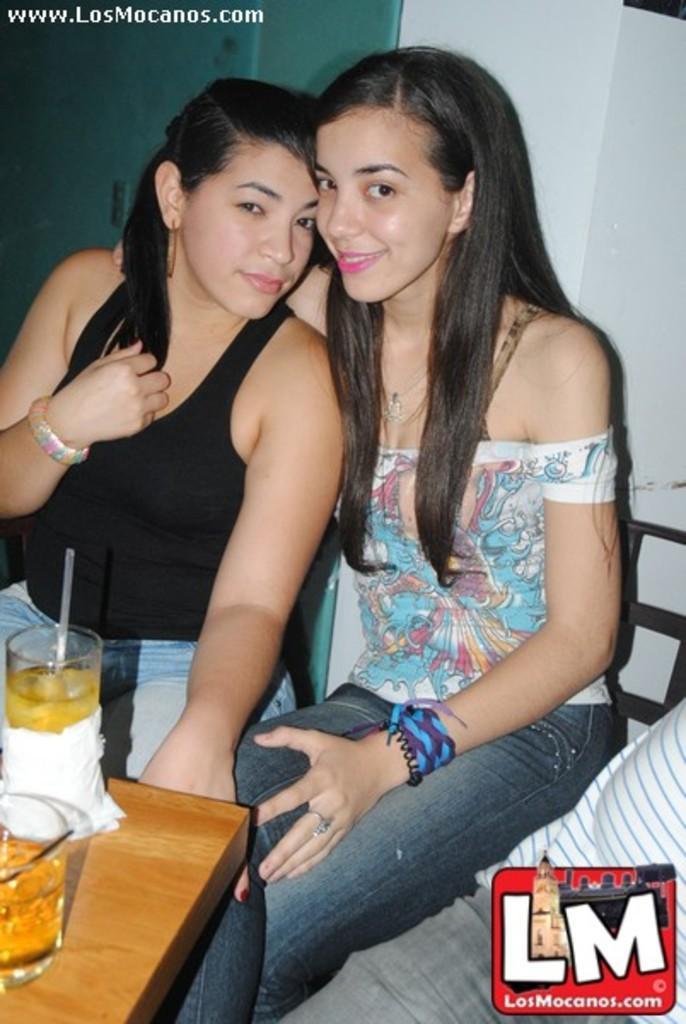Describe this image in one or two sentences. This image consists of two ladies. They are sitting. There is a table in front of them. On that table there are glasses. It is in the bottom left corner. 